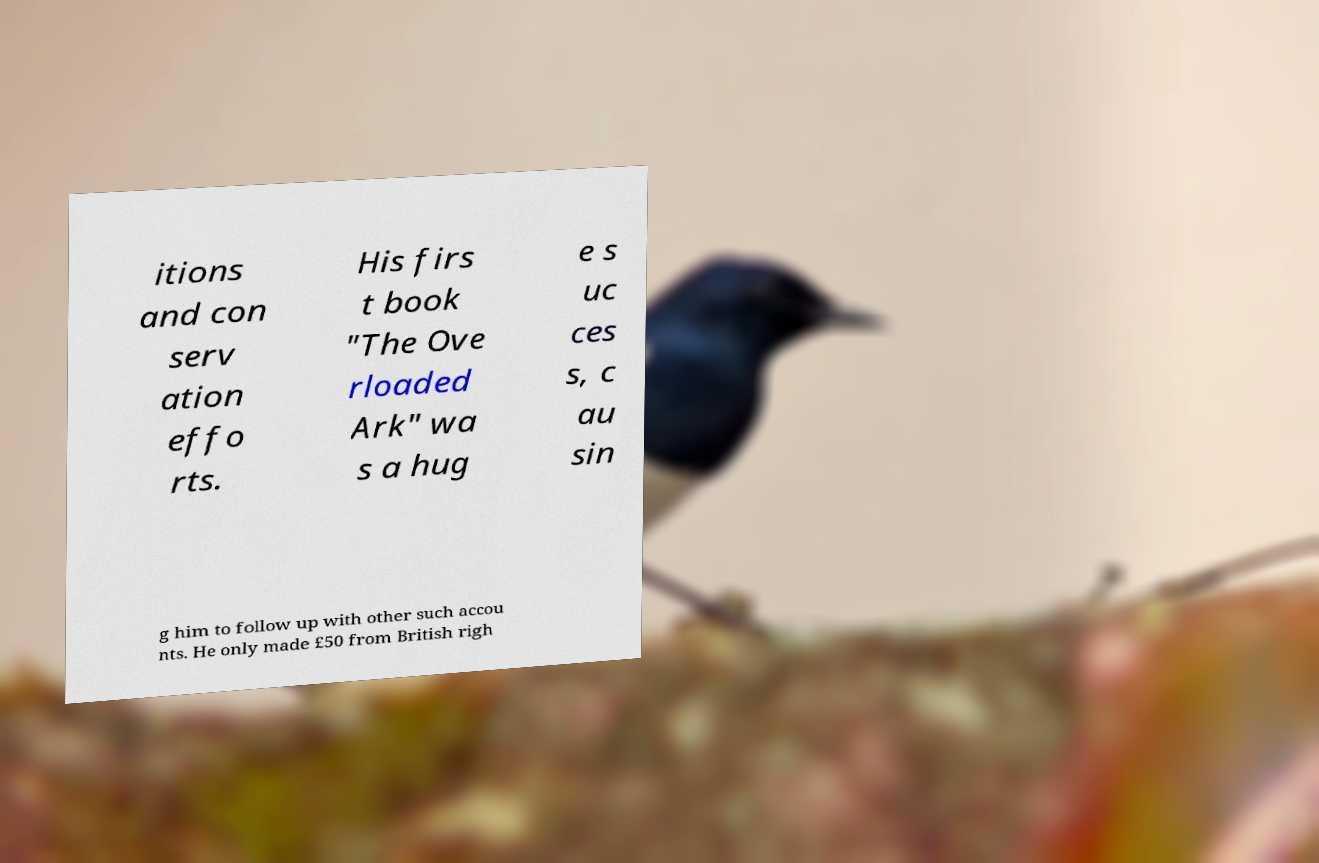For documentation purposes, I need the text within this image transcribed. Could you provide that? itions and con serv ation effo rts. His firs t book "The Ove rloaded Ark" wa s a hug e s uc ces s, c au sin g him to follow up with other such accou nts. He only made £50 from British righ 